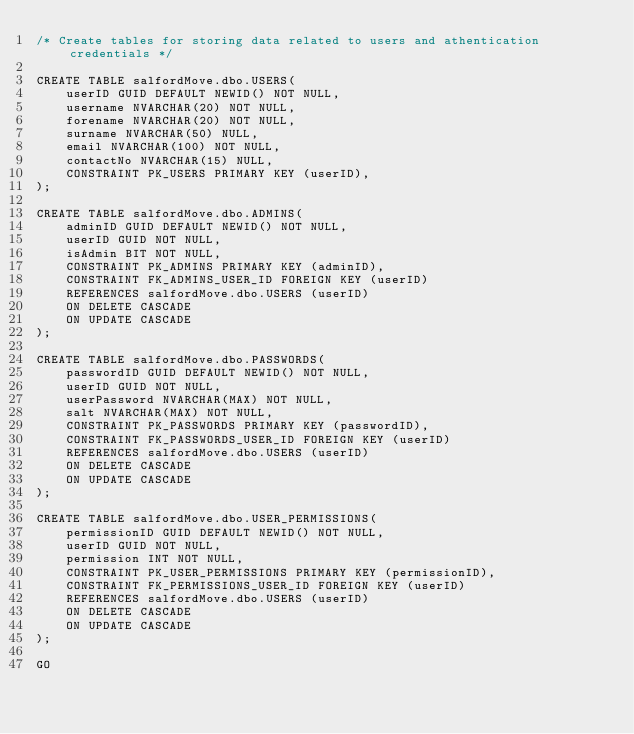<code> <loc_0><loc_0><loc_500><loc_500><_SQL_>/* Create tables for storing data related to users and athentication credentials */

CREATE TABLE salfordMove.dbo.USERS(
	userID GUID DEFAULT NEWID() NOT NULL,
	username NVARCHAR(20) NOT NULL,
	forename NVARCHAR(20) NOT NULL,
	surname NVARCHAR(50) NULL,
	email NVARCHAR(100) NOT NULL,
	contactNo NVARCHAR(15) NULL,
	CONSTRAINT PK_USERS PRIMARY KEY (userID),
);

CREATE TABLE salfordMove.dbo.ADMINS(
	adminID GUID DEFAULT NEWID() NOT NULL,
	userID GUID NOT NULL,
	isAdmin BIT NOT NULL,
	CONSTRAINT PK_ADMINS PRIMARY KEY (adminID),
	CONSTRAINT FK_ADMINS_USER_ID FOREIGN KEY (userID)
	REFERENCES salfordMove.dbo.USERS (userID)
	ON DELETE CASCADE
	ON UPDATE CASCADE
);

CREATE TABLE salfordMove.dbo.PASSWORDS(
	passwordID GUID DEFAULT NEWID() NOT NULL,
	userID GUID NOT NULL,
	userPassword NVARCHAR(MAX) NOT NULL,
	salt NVARCHAR(MAX) NOT NULL,
	CONSTRAINT PK_PASSWORDS PRIMARY KEY (passwordID),
	CONSTRAINT FK_PASSWORDS_USER_ID FOREIGN KEY (userID)
	REFERENCES salfordMove.dbo.USERS (userID)
	ON DELETE CASCADE
	ON UPDATE CASCADE
);

CREATE TABLE salfordMove.dbo.USER_PERMISSIONS(
	permissionID GUID DEFAULT NEWID() NOT NULL,
	userID GUID NOT NULL,
	permission INT NOT NULL,
	CONSTRAINT PK_USER_PERMISSIONS PRIMARY KEY (permissionID),
	CONSTRAINT FK_PERMISSIONS_USER_ID FOREIGN KEY (userID)
	REFERENCES salfordMove.dbo.USERS (userID)
	ON DELETE CASCADE
	ON UPDATE CASCADE
);

GO</code> 